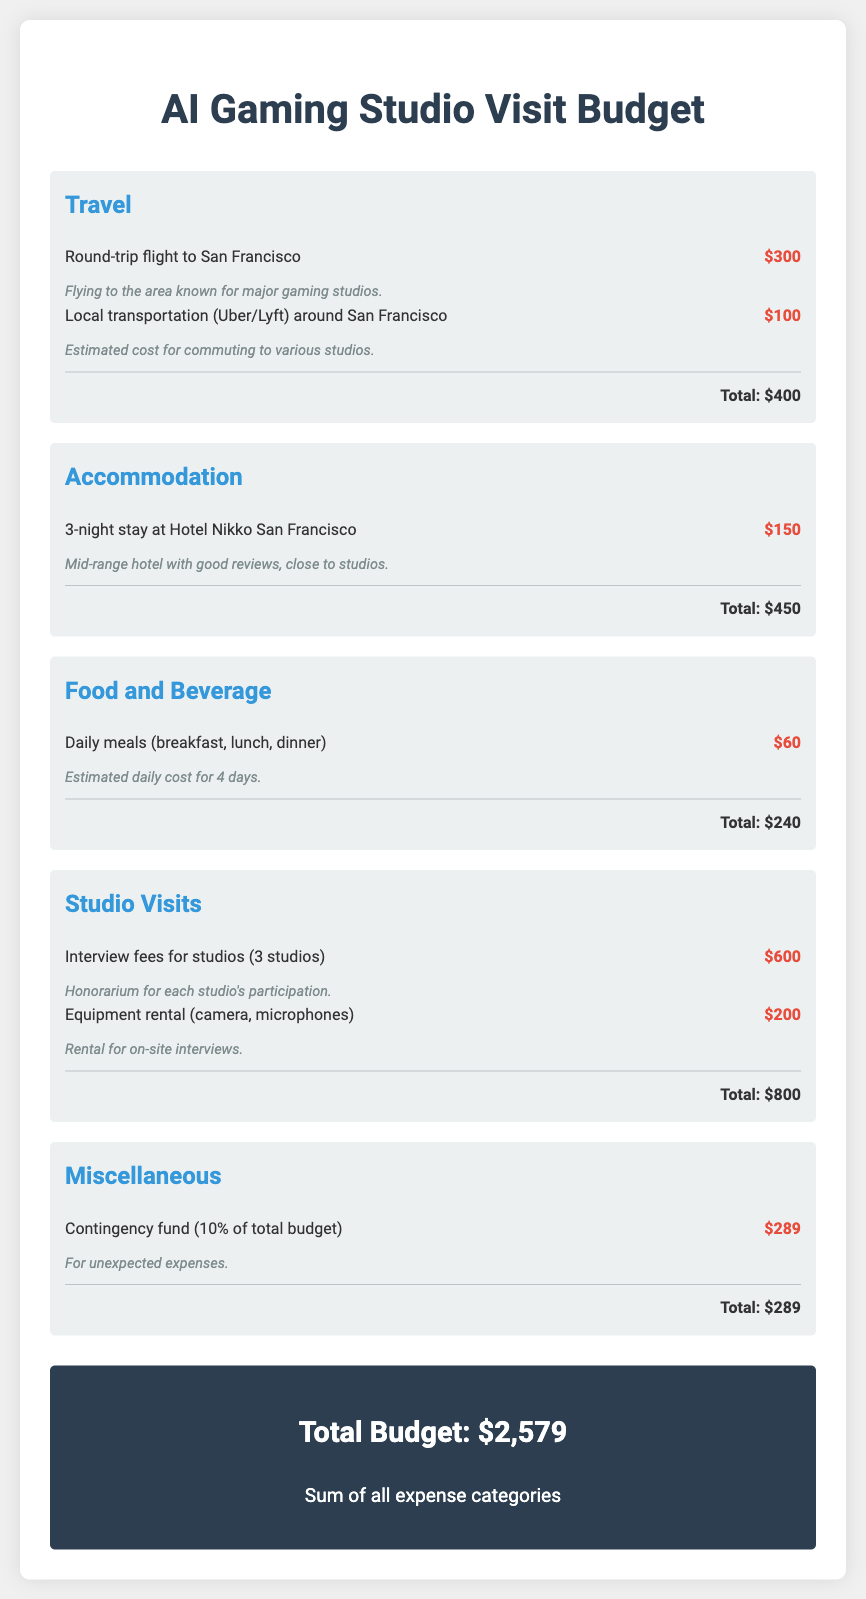what is the total budget? The total budget is shown at the bottom of the document, totaling all expense categories.
Answer: $2,579 how much is allocated for travel? Travel expenses are detailed in a specific category, showing the total cost associated with travel.
Answer: $400 what is the cost of the interview fees for studios? The document lists the interview fees for studios under the 'Studio Visits' category with a specific amount.
Answer: $600 how many nights is accommodation covered for? The accommodation section specifies the number of nights for the stay at the hotel.
Answer: 3 what percentage of the budget is the contingency fund? The contingency fund is specified as 10% of the total budget in the miscellaneous category.
Answer: 10% how much is included for daily meals? The food and beverage section specifies the estimated cost for daily meals across multiple days.
Answer: $60 what is the purpose of the equipment rental? The document provides a note indicating the purpose of the equipment rental listed under studio visits.
Answer: On-site interviews how much is the local transportation budget? The local transportation cost is detailed in the travel category, indicating how much is allocated.
Answer: $100 what type of hotel is included in the accommodation category? The accommodation section describes the hotel type based on its reviews and location relative to the studios.
Answer: Mid-range hotel 